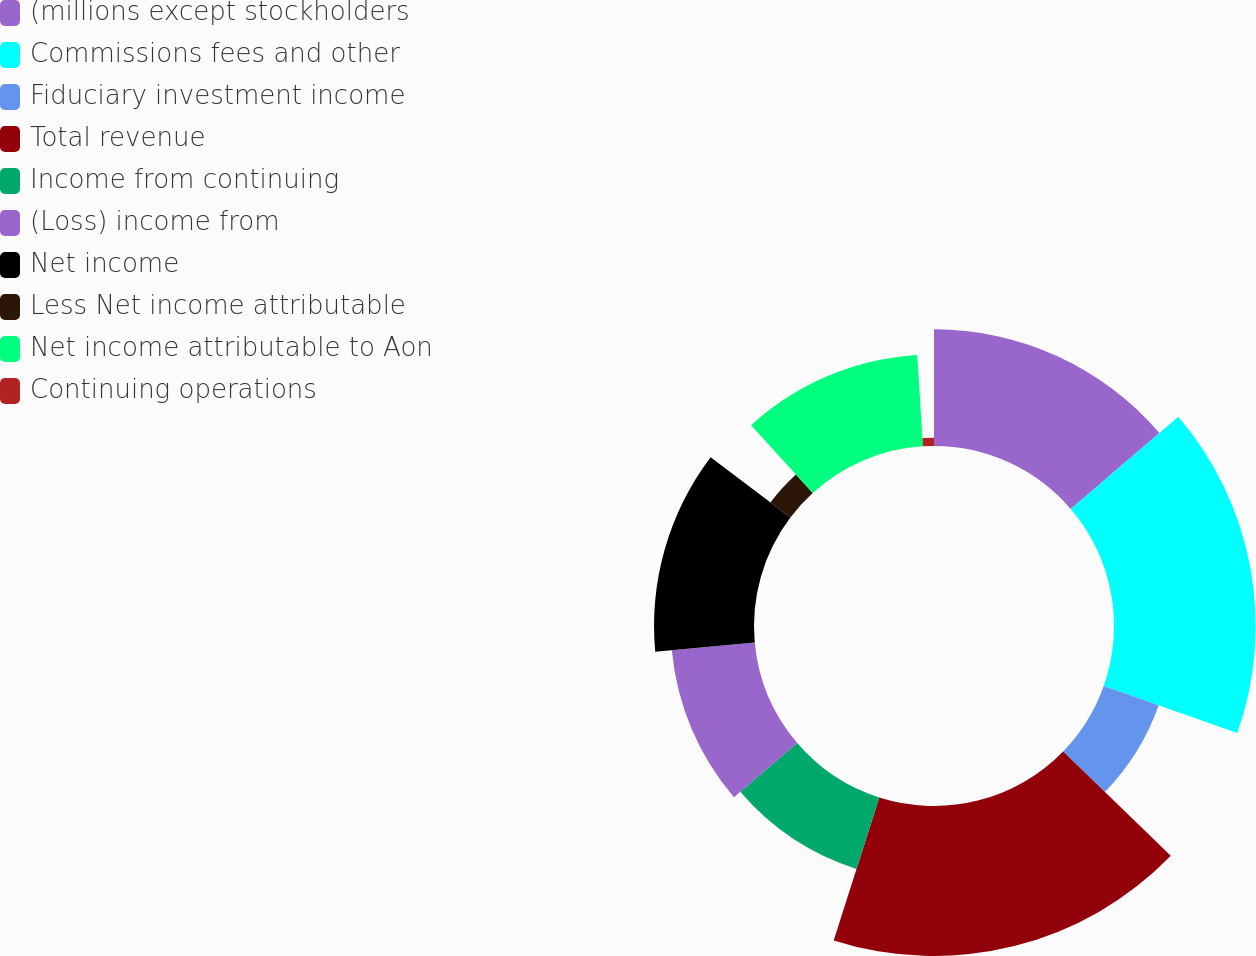<chart> <loc_0><loc_0><loc_500><loc_500><pie_chart><fcel>(millions except stockholders<fcel>Commissions fees and other<fcel>Fiduciary investment income<fcel>Total revenue<fcel>Income from continuing<fcel>(Loss) income from<fcel>Net income<fcel>Less Net income attributable<fcel>Net income attributable to Aon<fcel>Continuing operations<nl><fcel>13.73%<fcel>16.67%<fcel>6.86%<fcel>17.65%<fcel>8.82%<fcel>9.8%<fcel>11.76%<fcel>2.94%<fcel>10.78%<fcel>0.98%<nl></chart> 